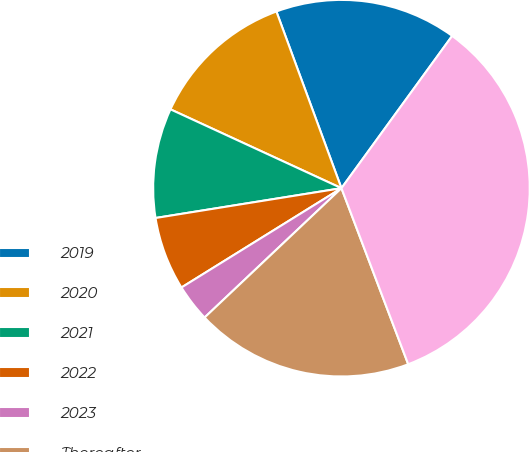Convert chart to OTSL. <chart><loc_0><loc_0><loc_500><loc_500><pie_chart><fcel>2019<fcel>2020<fcel>2021<fcel>2022<fcel>2023<fcel>Thereafter<fcel>Total minimum payments<nl><fcel>15.62%<fcel>12.51%<fcel>9.41%<fcel>6.31%<fcel>3.21%<fcel>18.72%<fcel>34.23%<nl></chart> 